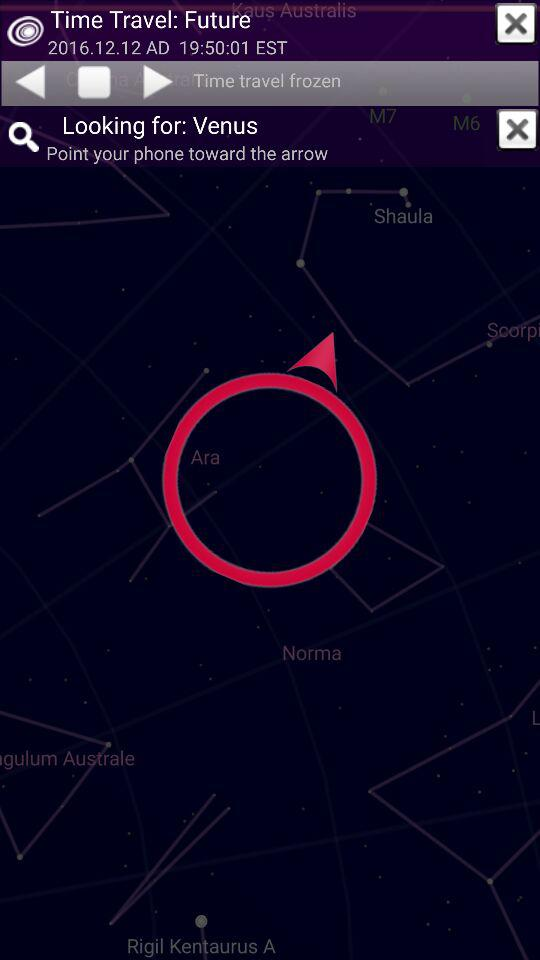What is the date for "Time Travel: Future"? The date for "Time Travel: Future" is December 12, 2016. 